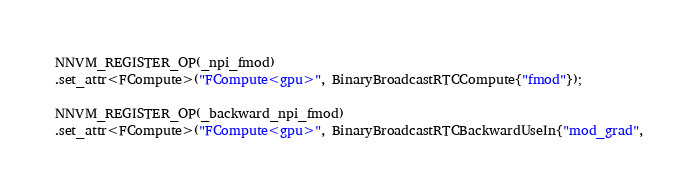<code> <loc_0><loc_0><loc_500><loc_500><_Cuda_>NNVM_REGISTER_OP(_npi_fmod)
.set_attr<FCompute>("FCompute<gpu>", BinaryBroadcastRTCCompute{"fmod"});

NNVM_REGISTER_OP(_backward_npi_fmod)
.set_attr<FCompute>("FCompute<gpu>", BinaryBroadcastRTCBackwardUseIn{"mod_grad",</code> 